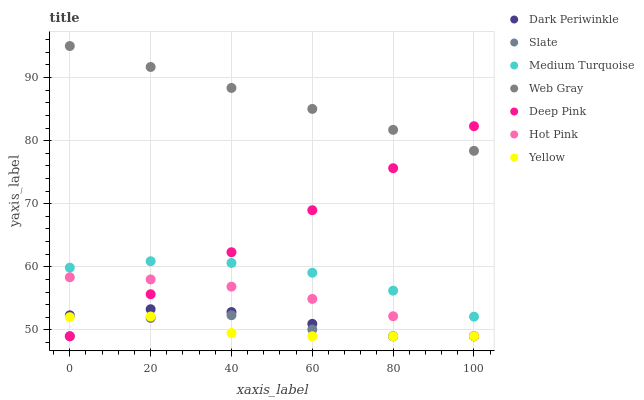Does Yellow have the minimum area under the curve?
Answer yes or no. Yes. Does Web Gray have the maximum area under the curve?
Answer yes or no. Yes. Does Slate have the minimum area under the curve?
Answer yes or no. No. Does Slate have the maximum area under the curve?
Answer yes or no. No. Is Web Gray the smoothest?
Answer yes or no. Yes. Is Slate the roughest?
Answer yes or no. Yes. Is Hot Pink the smoothest?
Answer yes or no. No. Is Hot Pink the roughest?
Answer yes or no. No. Does Slate have the lowest value?
Answer yes or no. Yes. Does Medium Turquoise have the lowest value?
Answer yes or no. No. Does Web Gray have the highest value?
Answer yes or no. Yes. Does Slate have the highest value?
Answer yes or no. No. Is Slate less than Medium Turquoise?
Answer yes or no. Yes. Is Web Gray greater than Yellow?
Answer yes or no. Yes. Does Yellow intersect Slate?
Answer yes or no. Yes. Is Yellow less than Slate?
Answer yes or no. No. Is Yellow greater than Slate?
Answer yes or no. No. Does Slate intersect Medium Turquoise?
Answer yes or no. No. 